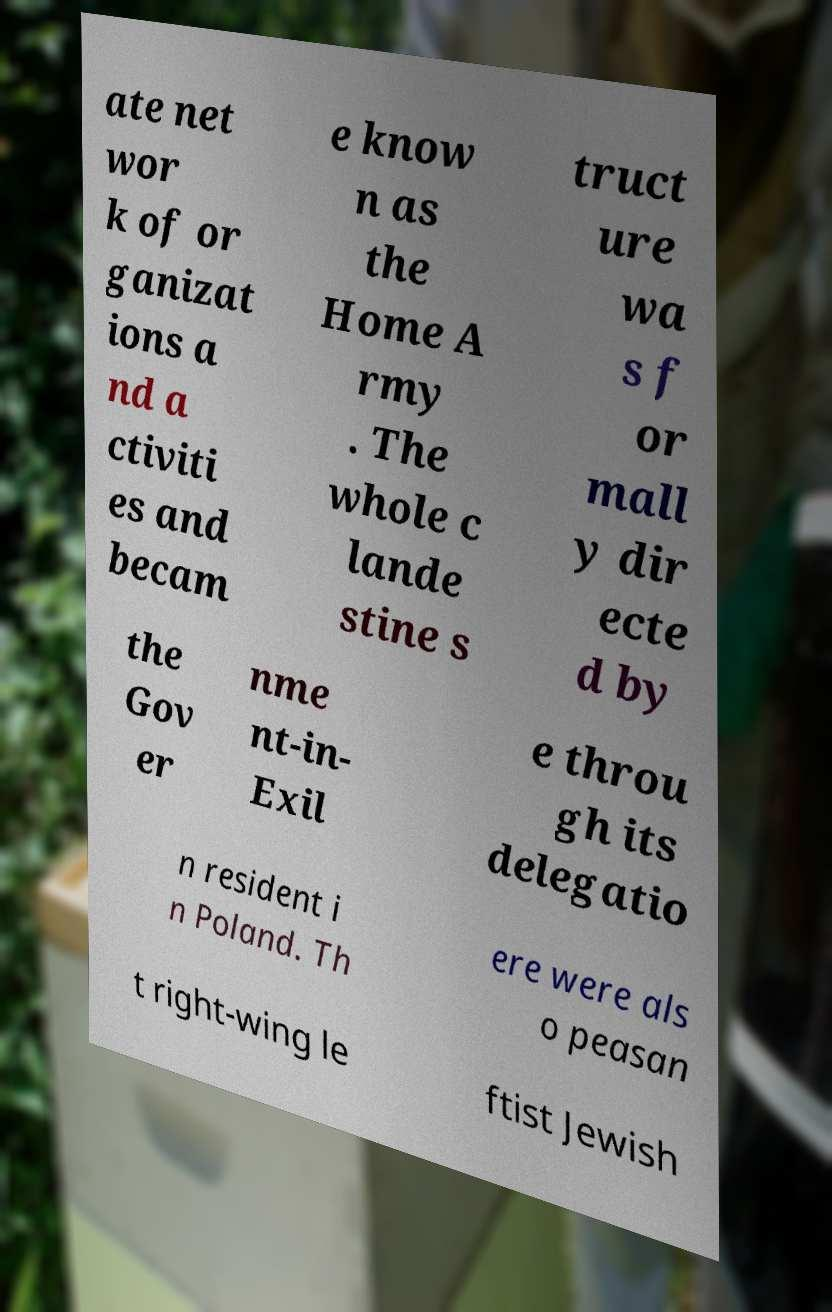Can you read and provide the text displayed in the image?This photo seems to have some interesting text. Can you extract and type it out for me? ate net wor k of or ganizat ions a nd a ctiviti es and becam e know n as the Home A rmy . The whole c lande stine s truct ure wa s f or mall y dir ecte d by the Gov er nme nt-in- Exil e throu gh its delegatio n resident i n Poland. Th ere were als o peasan t right-wing le ftist Jewish 